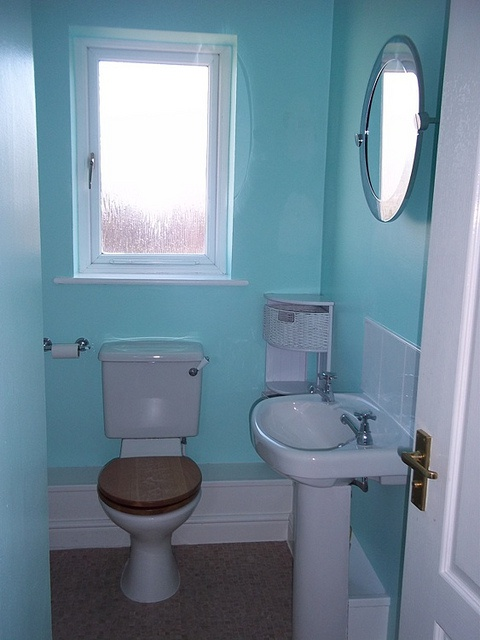Describe the objects in this image and their specific colors. I can see toilet in teal, gray, and black tones and sink in teal and gray tones in this image. 